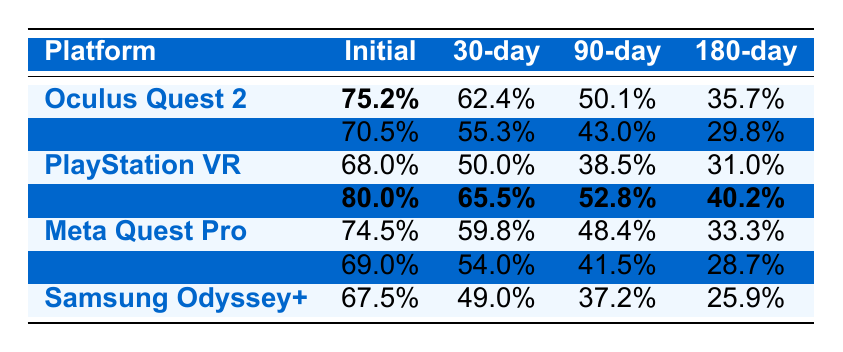What is the initial retention rate for the Oculus Quest 2? Referring to the table, the initial retention rate for the Oculus Quest 2 is directly given as 75.2%.
Answer: 75.2% Which platform has the highest 90-day retention rate? By examining the 90-day retention rates in the table, Valve Index has the highest value at 52.8%, compared to others.
Answer: Valve Index What is the average 30-day retention rate for all platforms? To find the average, add all 30-day rates: (62.4 + 55.3 + 50.0 + 65.5 + 59.8 + 54.0 + 49.0) = 406.0%, and divide by 7 platforms: 406.0% / 7 ≈ 58.0%.
Answer: 58.0% Is the 180-day retention rate for PlayStation VR higher than that of Samsung Odyssey+? Looking at the 180-day retention rates, PlayStation VR has 31.0% while Samsung Odyssey+ has 25.9%. Since 31.0% is greater than 25.9%, the statement is true.
Answer: Yes What is the difference between the highest and lowest initial retention rates? Identify the highest initial retention rate (Valve Index at 80.0%) and the lowest (Samsung Odyssey+ at 67.5%). The difference is 80.0% - 67.5% = 12.5%.
Answer: 12.5% Which platform shows a larger decline from the initial to the 180-day retention rate? The retention decline for each platform can be calculated: Oculus Quest 2 (75.2% - 35.7% = 39.5%), HTC Vive Pro (70.5% - 29.8% = 40.7%), PlayStation VR (68.0% - 31.0% = 37.0%), Valve Index (80.0% - 40.2% = 39.8%), Meta Quest Pro (74.5% - 33.3% = 41.2%), Pico Neo 3 (69.0% - 28.7% = 40.3%), Samsung Odyssey+ (67.5% - 25.9% = 41.6%). The highest decline is for Samsung Odyssey+ at 41.6%.
Answer: Samsung Odyssey+ If the initial retention rates for HTC Vive Pro and Samsung Odyssey+ were combined, what percentage would that be? The combined initial retention rates would be 70.5% (HTC Vive Pro) + 67.5% (Samsung Odyssey+) = 138.0%.
Answer: 138.0% What percentage of users are retained after 30 days on the Valve Index? The table shows the Valve Index's 30-day retention rate as 65.5%.
Answer: 65.5% Is there a platform with over 60% retention at the 90-day mark? Referencing the 90-day rates, only Valve Index (52.8%) meets this criterion; therefore, this statement is false.
Answer: No 